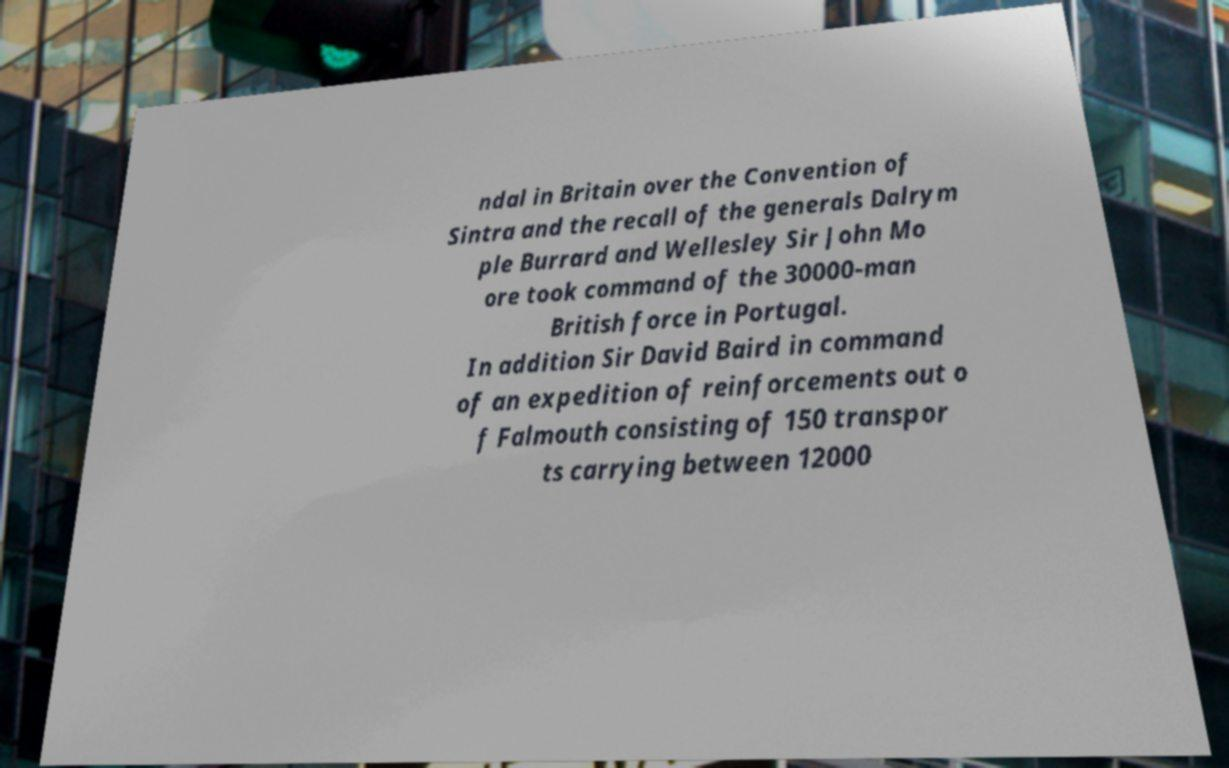What messages or text are displayed in this image? I need them in a readable, typed format. ndal in Britain over the Convention of Sintra and the recall of the generals Dalrym ple Burrard and Wellesley Sir John Mo ore took command of the 30000-man British force in Portugal. In addition Sir David Baird in command of an expedition of reinforcements out o f Falmouth consisting of 150 transpor ts carrying between 12000 